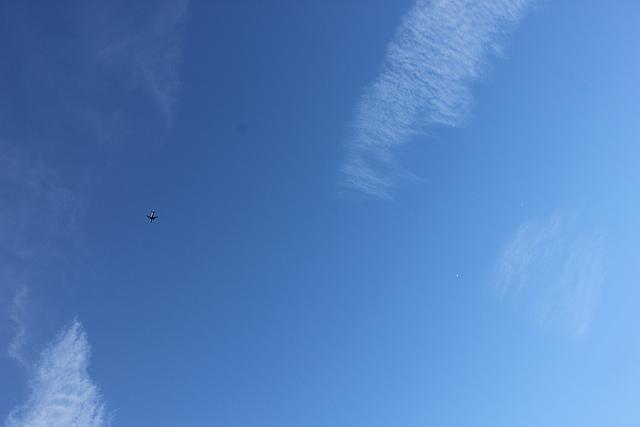How many umbrellas are here?
Give a very brief answer. 0. 